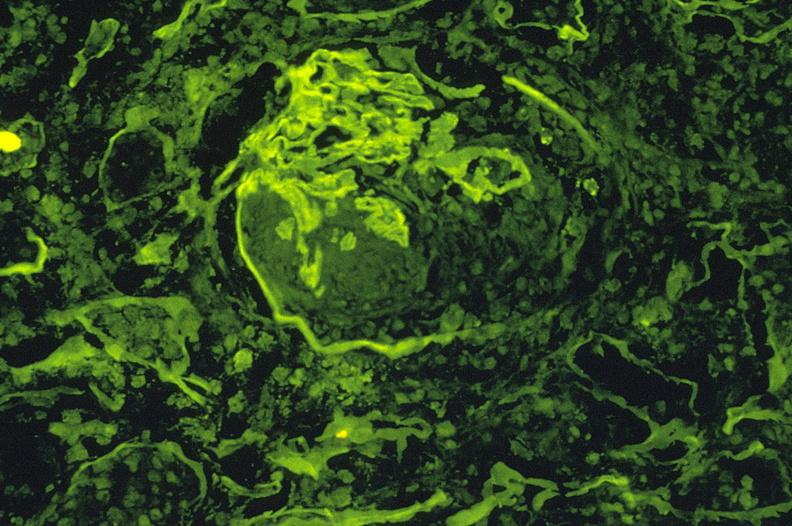s urinary present?
Answer the question using a single word or phrase. Yes 